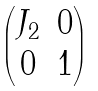<formula> <loc_0><loc_0><loc_500><loc_500>\begin{pmatrix} J _ { 2 } & 0 \\ 0 & 1 \end{pmatrix}</formula> 